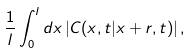Convert formula to latex. <formula><loc_0><loc_0><loc_500><loc_500>\frac { 1 } { l } \int _ { 0 } ^ { l } d x \left | C ( x , t | x + r , t ) \right | ,</formula> 